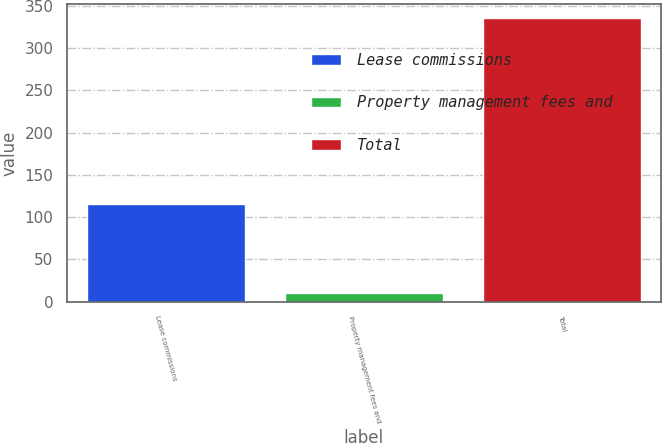Convert chart to OTSL. <chart><loc_0><loc_0><loc_500><loc_500><bar_chart><fcel>Lease commissions<fcel>Property management fees and<fcel>Total<nl><fcel>116<fcel>11<fcel>335<nl></chart> 